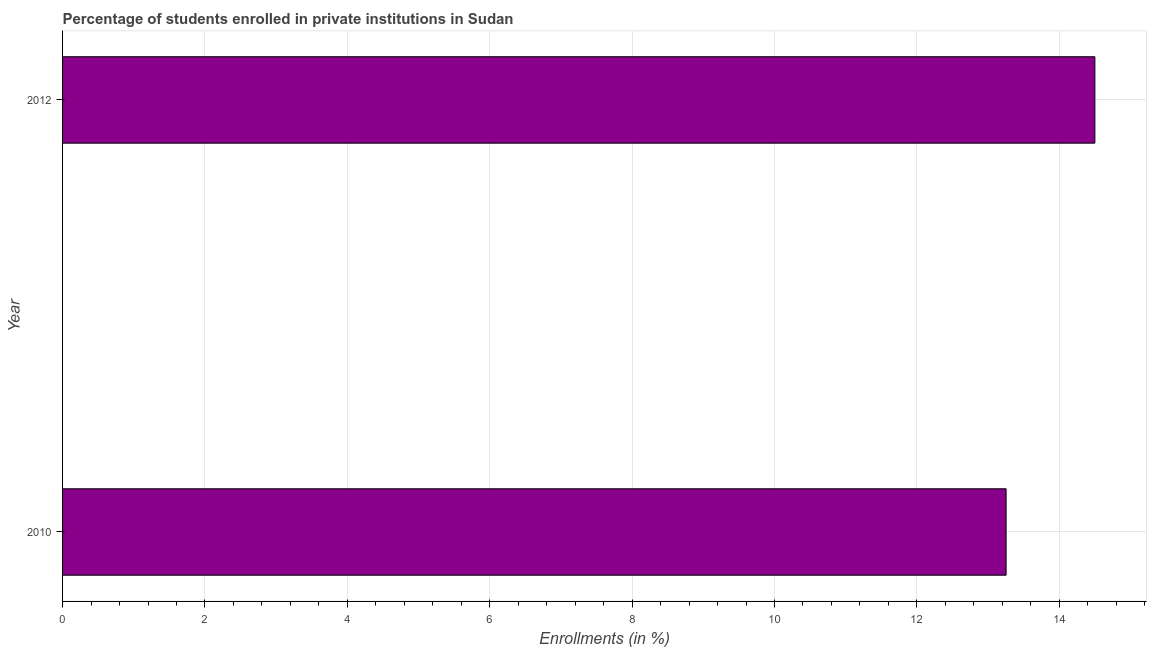Does the graph contain grids?
Offer a very short reply. Yes. What is the title of the graph?
Your answer should be compact. Percentage of students enrolled in private institutions in Sudan. What is the label or title of the X-axis?
Offer a terse response. Enrollments (in %). What is the label or title of the Y-axis?
Your answer should be compact. Year. What is the enrollments in private institutions in 2010?
Your answer should be very brief. 13.25. Across all years, what is the maximum enrollments in private institutions?
Ensure brevity in your answer.  14.5. Across all years, what is the minimum enrollments in private institutions?
Your answer should be compact. 13.25. In which year was the enrollments in private institutions minimum?
Make the answer very short. 2010. What is the sum of the enrollments in private institutions?
Keep it short and to the point. 27.75. What is the difference between the enrollments in private institutions in 2010 and 2012?
Your response must be concise. -1.25. What is the average enrollments in private institutions per year?
Provide a short and direct response. 13.88. What is the median enrollments in private institutions?
Your response must be concise. 13.88. What is the ratio of the enrollments in private institutions in 2010 to that in 2012?
Offer a very short reply. 0.91. How many years are there in the graph?
Offer a very short reply. 2. Are the values on the major ticks of X-axis written in scientific E-notation?
Your answer should be compact. No. What is the Enrollments (in %) in 2010?
Your response must be concise. 13.25. What is the Enrollments (in %) of 2012?
Give a very brief answer. 14.5. What is the difference between the Enrollments (in %) in 2010 and 2012?
Ensure brevity in your answer.  -1.25. What is the ratio of the Enrollments (in %) in 2010 to that in 2012?
Offer a very short reply. 0.91. 